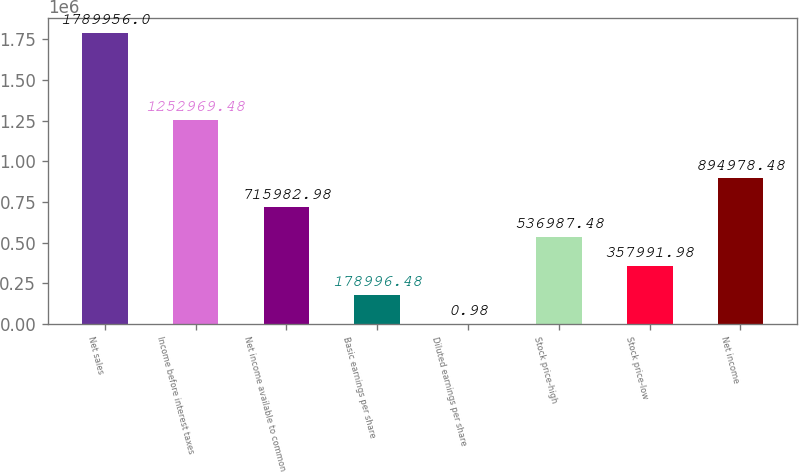Convert chart to OTSL. <chart><loc_0><loc_0><loc_500><loc_500><bar_chart><fcel>Net sales<fcel>Income before interest taxes<fcel>Net income available to common<fcel>Basic earnings per share<fcel>Diluted earnings per share<fcel>Stock price-high<fcel>Stock price-low<fcel>Net income<nl><fcel>1.78996e+06<fcel>1.25297e+06<fcel>715983<fcel>178996<fcel>0.98<fcel>536987<fcel>357992<fcel>894978<nl></chart> 